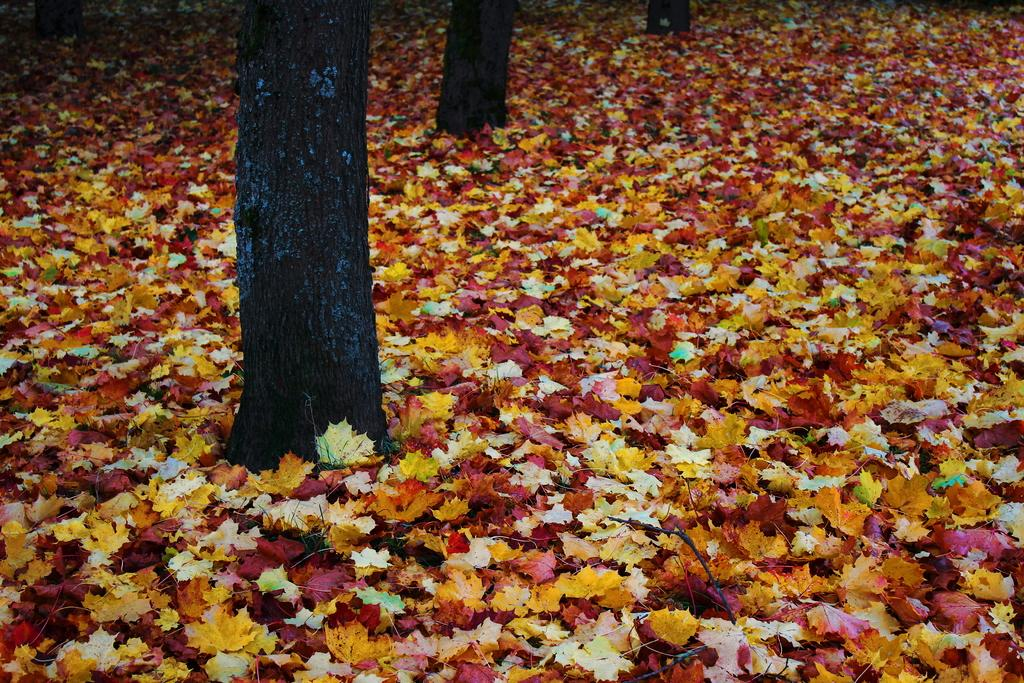What type of vegetation can be seen in the image? There are trees in the image. What is present on the ground beneath the trees? There are leaves on the ground in the image. What can be observed about the color of the leaves? The leaves are in different colors. What type of music can be heard coming from the carriage in the image? There is no carriage present in the image, so it's not possible to determine what, if any, music might be heard. 